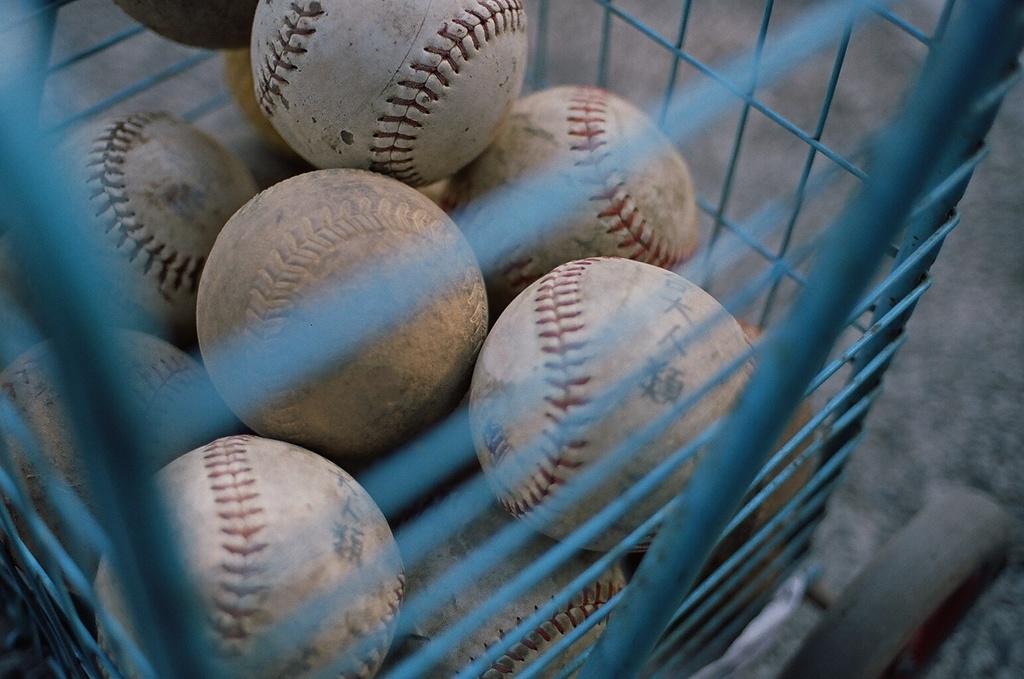Please provide a concise description of this image. In this image we can see balls in a grill trolley. 